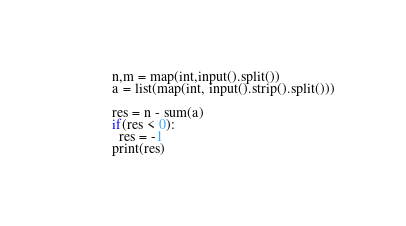<code> <loc_0><loc_0><loc_500><loc_500><_Python_>n,m = map(int,input().split())
a = list(map(int, input().strip().split()))

res = n - sum(a)
if(res < 0):
  res = -1
print(res)

</code> 